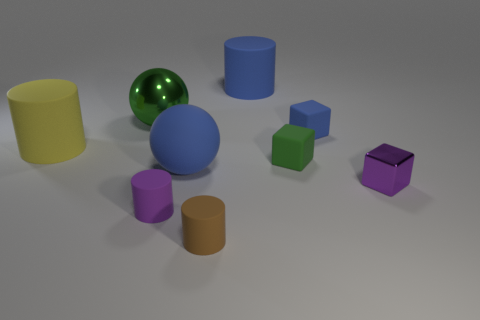Subtract all small purple blocks. How many blocks are left? 2 Subtract all spheres. How many objects are left? 7 Subtract 3 blocks. How many blocks are left? 0 Subtract all blue cylinders. Subtract all cyan spheres. How many cylinders are left? 3 Subtract all gray spheres. How many purple cubes are left? 1 Subtract all green shiny objects. Subtract all large blue rubber spheres. How many objects are left? 7 Add 3 purple matte cylinders. How many purple matte cylinders are left? 4 Add 6 purple metallic things. How many purple metallic things exist? 7 Subtract all blue balls. How many balls are left? 1 Subtract 1 purple cylinders. How many objects are left? 8 